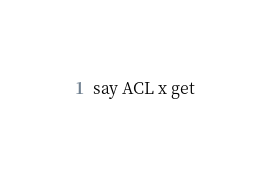<code> <loc_0><loc_0><loc_500><loc_500><_Perl_>say ACL x get</code> 